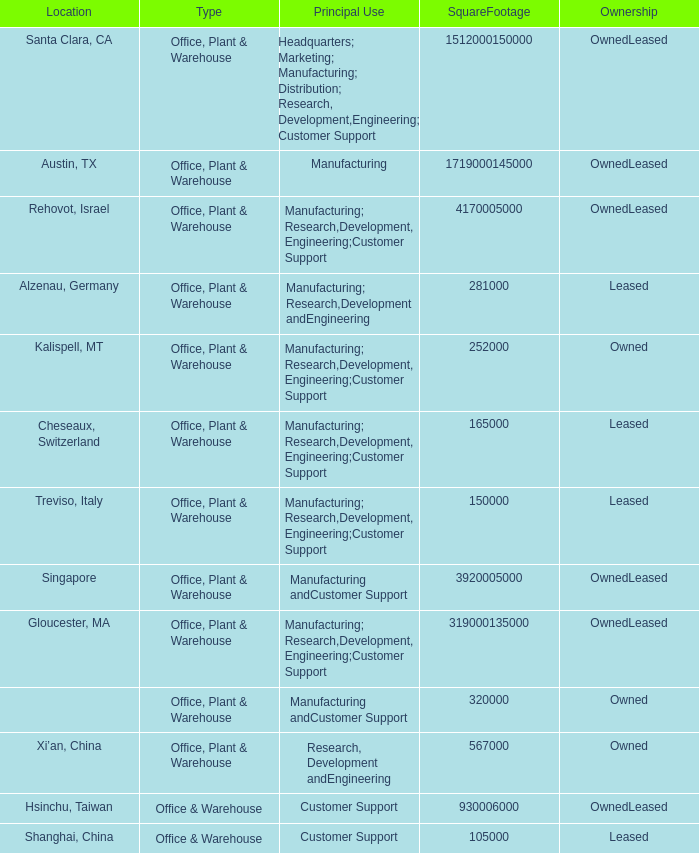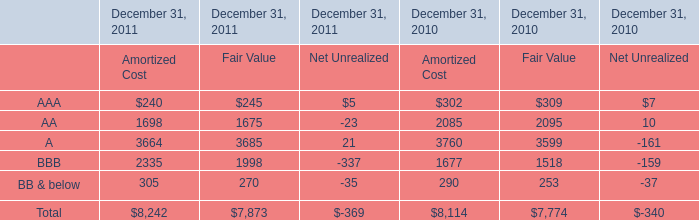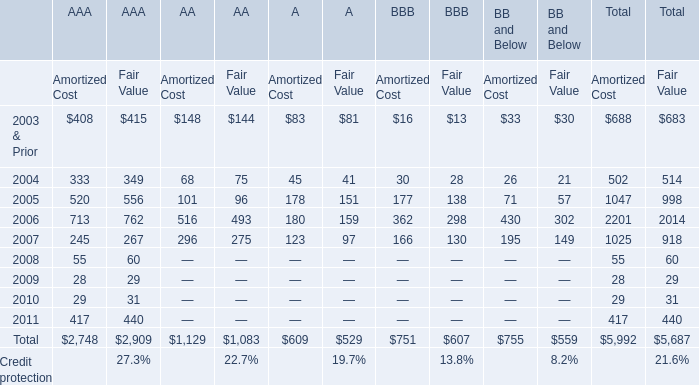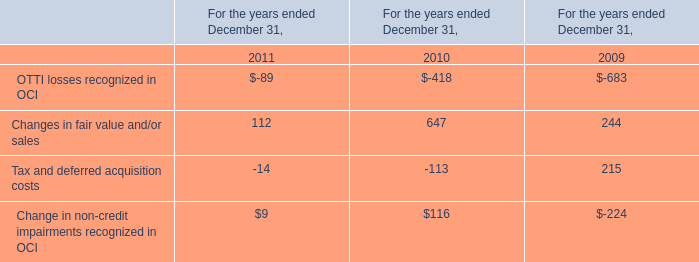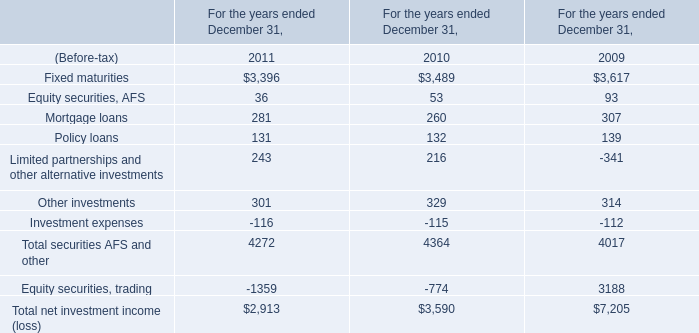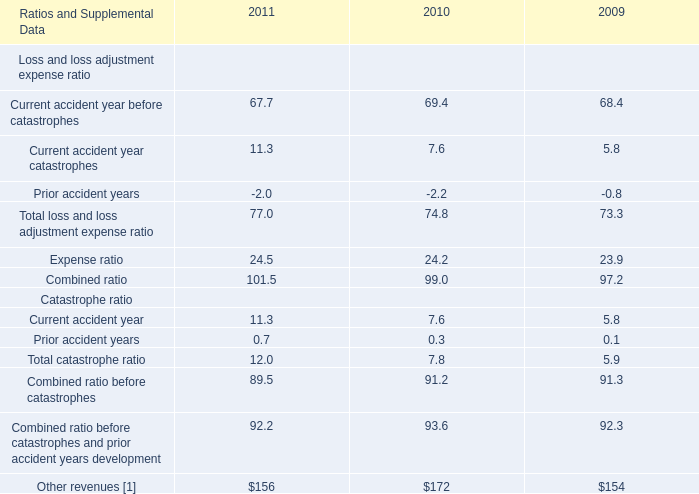What's the average of Fixed maturities of For the years ended December 31, 2009, and Hsinchu, Taiwan of SquareFootage 1,512,000150,000 ? 
Computations: ((3617.0 + 930006000.0) / 2)
Answer: 465004808.5. 